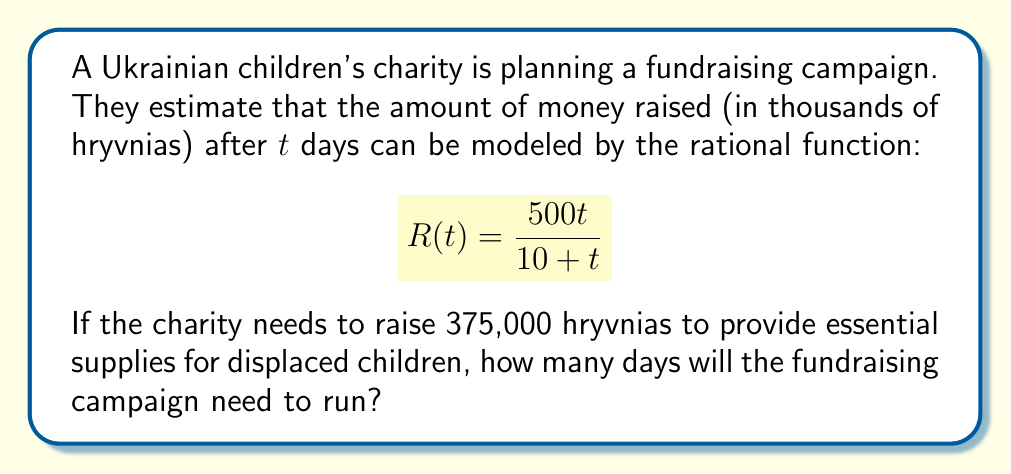Teach me how to tackle this problem. To solve this problem, we need to follow these steps:

1) We're looking for the time $t$ when $R(t) = 375$ (since R(t) is in thousands of hryvnias).

2) Set up the equation:

   $$\frac{500t}{10 + t} = 375$$

3) Multiply both sides by $(10 + t)$:

   $$500t = 375(10 + t)$$

4) Expand the right side:

   $$500t = 3750 + 375t$$

5) Subtract $375t$ from both sides:

   $$125t = 3750$$

6) Divide both sides by 125:

   $$t = 30$$

Therefore, the fundraising campaign will need to run for 30 days to reach the target of 375,000 hryvnias.

To verify:
$$R(30) = \frac{500(30)}{10 + 30} = \frac{15000}{40} = 375$$

This confirms our solution is correct.
Answer: 30 days 